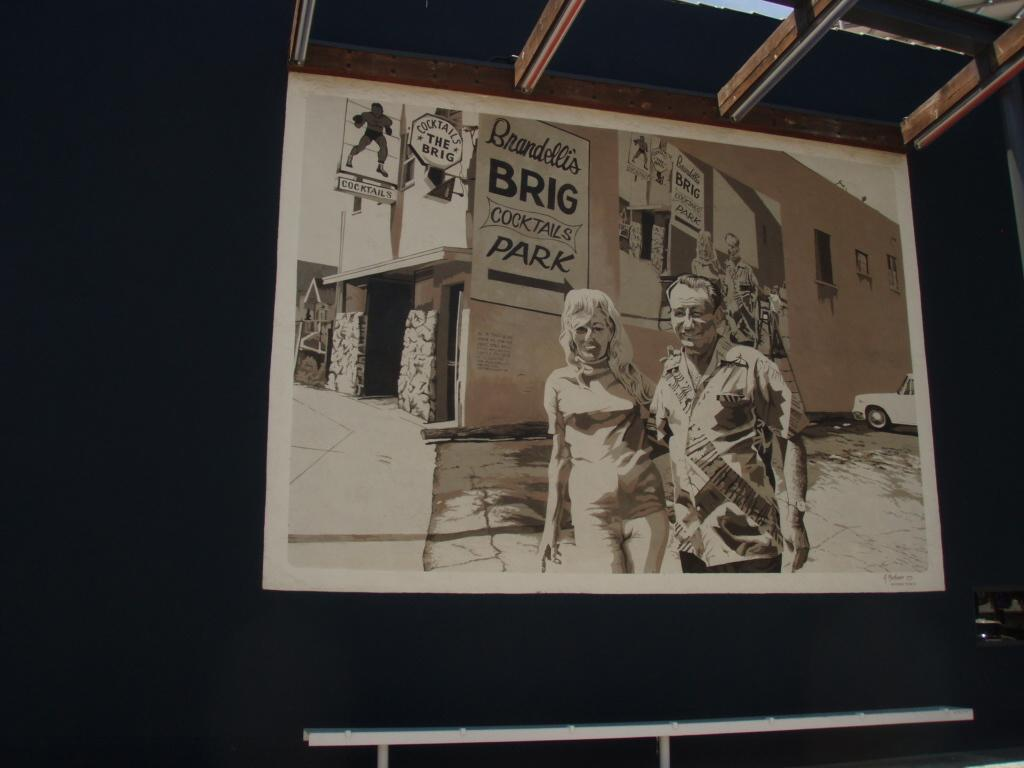<image>
Relay a brief, clear account of the picture shown. Picture showing a man and woman holding hands in front of a building called The Brig. 